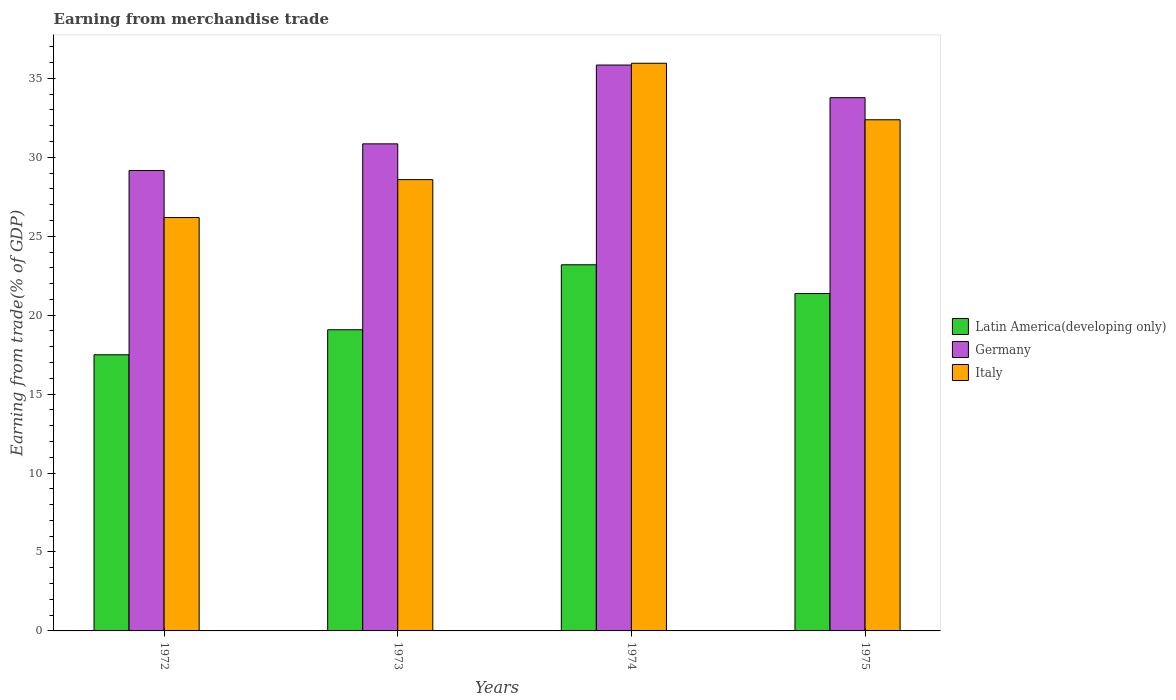How many groups of bars are there?
Give a very brief answer. 4. Are the number of bars per tick equal to the number of legend labels?
Provide a succinct answer. Yes. How many bars are there on the 3rd tick from the left?
Keep it short and to the point. 3. How many bars are there on the 2nd tick from the right?
Ensure brevity in your answer.  3. What is the label of the 2nd group of bars from the left?
Ensure brevity in your answer.  1973. In how many cases, is the number of bars for a given year not equal to the number of legend labels?
Provide a succinct answer. 0. What is the earnings from trade in Germany in 1975?
Your response must be concise. 33.78. Across all years, what is the maximum earnings from trade in Germany?
Provide a short and direct response. 35.85. Across all years, what is the minimum earnings from trade in Germany?
Your response must be concise. 29.17. In which year was the earnings from trade in Latin America(developing only) maximum?
Your answer should be very brief. 1974. In which year was the earnings from trade in Latin America(developing only) minimum?
Provide a succinct answer. 1972. What is the total earnings from trade in Italy in the graph?
Provide a short and direct response. 123.12. What is the difference between the earnings from trade in Germany in 1973 and that in 1975?
Offer a terse response. -2.92. What is the difference between the earnings from trade in Latin America(developing only) in 1973 and the earnings from trade in Italy in 1972?
Provide a short and direct response. -7.11. What is the average earnings from trade in Italy per year?
Provide a short and direct response. 30.78. In the year 1972, what is the difference between the earnings from trade in Germany and earnings from trade in Latin America(developing only)?
Provide a succinct answer. 11.67. In how many years, is the earnings from trade in Italy greater than 6 %?
Offer a terse response. 4. What is the ratio of the earnings from trade in Germany in 1973 to that in 1975?
Offer a very short reply. 0.91. What is the difference between the highest and the second highest earnings from trade in Latin America(developing only)?
Your answer should be very brief. 1.82. What is the difference between the highest and the lowest earnings from trade in Italy?
Your answer should be very brief. 9.77. In how many years, is the earnings from trade in Italy greater than the average earnings from trade in Italy taken over all years?
Keep it short and to the point. 2. What does the 2nd bar from the right in 1974 represents?
Your response must be concise. Germany. Are all the bars in the graph horizontal?
Your response must be concise. No. How many years are there in the graph?
Provide a succinct answer. 4. What is the difference between two consecutive major ticks on the Y-axis?
Make the answer very short. 5. Does the graph contain grids?
Keep it short and to the point. No. How many legend labels are there?
Give a very brief answer. 3. How are the legend labels stacked?
Ensure brevity in your answer.  Vertical. What is the title of the graph?
Your answer should be compact. Earning from merchandise trade. What is the label or title of the Y-axis?
Offer a very short reply. Earning from trade(% of GDP). What is the Earning from trade(% of GDP) in Latin America(developing only) in 1972?
Give a very brief answer. 17.49. What is the Earning from trade(% of GDP) of Germany in 1972?
Your answer should be compact. 29.17. What is the Earning from trade(% of GDP) of Italy in 1972?
Give a very brief answer. 26.19. What is the Earning from trade(% of GDP) of Latin America(developing only) in 1973?
Offer a terse response. 19.08. What is the Earning from trade(% of GDP) in Germany in 1973?
Give a very brief answer. 30.86. What is the Earning from trade(% of GDP) of Italy in 1973?
Your response must be concise. 28.59. What is the Earning from trade(% of GDP) of Latin America(developing only) in 1974?
Your answer should be compact. 23.19. What is the Earning from trade(% of GDP) in Germany in 1974?
Make the answer very short. 35.85. What is the Earning from trade(% of GDP) in Italy in 1974?
Offer a very short reply. 35.96. What is the Earning from trade(% of GDP) in Latin America(developing only) in 1975?
Offer a terse response. 21.38. What is the Earning from trade(% of GDP) in Germany in 1975?
Give a very brief answer. 33.78. What is the Earning from trade(% of GDP) in Italy in 1975?
Your response must be concise. 32.38. Across all years, what is the maximum Earning from trade(% of GDP) in Latin America(developing only)?
Your answer should be compact. 23.19. Across all years, what is the maximum Earning from trade(% of GDP) in Germany?
Your answer should be compact. 35.85. Across all years, what is the maximum Earning from trade(% of GDP) of Italy?
Offer a terse response. 35.96. Across all years, what is the minimum Earning from trade(% of GDP) of Latin America(developing only)?
Ensure brevity in your answer.  17.49. Across all years, what is the minimum Earning from trade(% of GDP) in Germany?
Keep it short and to the point. 29.17. Across all years, what is the minimum Earning from trade(% of GDP) of Italy?
Your response must be concise. 26.19. What is the total Earning from trade(% of GDP) in Latin America(developing only) in the graph?
Offer a terse response. 81.14. What is the total Earning from trade(% of GDP) in Germany in the graph?
Give a very brief answer. 129.65. What is the total Earning from trade(% of GDP) in Italy in the graph?
Keep it short and to the point. 123.12. What is the difference between the Earning from trade(% of GDP) of Latin America(developing only) in 1972 and that in 1973?
Your answer should be compact. -1.59. What is the difference between the Earning from trade(% of GDP) of Germany in 1972 and that in 1973?
Make the answer very short. -1.69. What is the difference between the Earning from trade(% of GDP) in Italy in 1972 and that in 1973?
Offer a terse response. -2.4. What is the difference between the Earning from trade(% of GDP) of Latin America(developing only) in 1972 and that in 1974?
Ensure brevity in your answer.  -5.7. What is the difference between the Earning from trade(% of GDP) in Germany in 1972 and that in 1974?
Your answer should be very brief. -6.68. What is the difference between the Earning from trade(% of GDP) in Italy in 1972 and that in 1974?
Your answer should be very brief. -9.77. What is the difference between the Earning from trade(% of GDP) of Latin America(developing only) in 1972 and that in 1975?
Offer a terse response. -3.88. What is the difference between the Earning from trade(% of GDP) in Germany in 1972 and that in 1975?
Your answer should be very brief. -4.61. What is the difference between the Earning from trade(% of GDP) of Italy in 1972 and that in 1975?
Offer a terse response. -6.19. What is the difference between the Earning from trade(% of GDP) of Latin America(developing only) in 1973 and that in 1974?
Your answer should be compact. -4.12. What is the difference between the Earning from trade(% of GDP) of Germany in 1973 and that in 1974?
Provide a short and direct response. -4.99. What is the difference between the Earning from trade(% of GDP) of Italy in 1973 and that in 1974?
Give a very brief answer. -7.37. What is the difference between the Earning from trade(% of GDP) in Latin America(developing only) in 1973 and that in 1975?
Offer a very short reply. -2.3. What is the difference between the Earning from trade(% of GDP) of Germany in 1973 and that in 1975?
Make the answer very short. -2.92. What is the difference between the Earning from trade(% of GDP) of Italy in 1973 and that in 1975?
Keep it short and to the point. -3.79. What is the difference between the Earning from trade(% of GDP) in Latin America(developing only) in 1974 and that in 1975?
Give a very brief answer. 1.82. What is the difference between the Earning from trade(% of GDP) in Germany in 1974 and that in 1975?
Your response must be concise. 2.07. What is the difference between the Earning from trade(% of GDP) of Italy in 1974 and that in 1975?
Offer a terse response. 3.58. What is the difference between the Earning from trade(% of GDP) of Latin America(developing only) in 1972 and the Earning from trade(% of GDP) of Germany in 1973?
Your answer should be compact. -13.36. What is the difference between the Earning from trade(% of GDP) in Latin America(developing only) in 1972 and the Earning from trade(% of GDP) in Italy in 1973?
Provide a succinct answer. -11.1. What is the difference between the Earning from trade(% of GDP) of Germany in 1972 and the Earning from trade(% of GDP) of Italy in 1973?
Your response must be concise. 0.58. What is the difference between the Earning from trade(% of GDP) in Latin America(developing only) in 1972 and the Earning from trade(% of GDP) in Germany in 1974?
Ensure brevity in your answer.  -18.35. What is the difference between the Earning from trade(% of GDP) of Latin America(developing only) in 1972 and the Earning from trade(% of GDP) of Italy in 1974?
Ensure brevity in your answer.  -18.47. What is the difference between the Earning from trade(% of GDP) of Germany in 1972 and the Earning from trade(% of GDP) of Italy in 1974?
Offer a terse response. -6.79. What is the difference between the Earning from trade(% of GDP) in Latin America(developing only) in 1972 and the Earning from trade(% of GDP) in Germany in 1975?
Ensure brevity in your answer.  -16.29. What is the difference between the Earning from trade(% of GDP) of Latin America(developing only) in 1972 and the Earning from trade(% of GDP) of Italy in 1975?
Your response must be concise. -14.89. What is the difference between the Earning from trade(% of GDP) in Germany in 1972 and the Earning from trade(% of GDP) in Italy in 1975?
Your answer should be very brief. -3.21. What is the difference between the Earning from trade(% of GDP) of Latin America(developing only) in 1973 and the Earning from trade(% of GDP) of Germany in 1974?
Give a very brief answer. -16.77. What is the difference between the Earning from trade(% of GDP) in Latin America(developing only) in 1973 and the Earning from trade(% of GDP) in Italy in 1974?
Your response must be concise. -16.88. What is the difference between the Earning from trade(% of GDP) of Germany in 1973 and the Earning from trade(% of GDP) of Italy in 1974?
Provide a short and direct response. -5.11. What is the difference between the Earning from trade(% of GDP) of Latin America(developing only) in 1973 and the Earning from trade(% of GDP) of Germany in 1975?
Your response must be concise. -14.7. What is the difference between the Earning from trade(% of GDP) in Latin America(developing only) in 1973 and the Earning from trade(% of GDP) in Italy in 1975?
Make the answer very short. -13.3. What is the difference between the Earning from trade(% of GDP) of Germany in 1973 and the Earning from trade(% of GDP) of Italy in 1975?
Make the answer very short. -1.53. What is the difference between the Earning from trade(% of GDP) in Latin America(developing only) in 1974 and the Earning from trade(% of GDP) in Germany in 1975?
Provide a short and direct response. -10.58. What is the difference between the Earning from trade(% of GDP) of Latin America(developing only) in 1974 and the Earning from trade(% of GDP) of Italy in 1975?
Your response must be concise. -9.19. What is the difference between the Earning from trade(% of GDP) in Germany in 1974 and the Earning from trade(% of GDP) in Italy in 1975?
Your answer should be very brief. 3.47. What is the average Earning from trade(% of GDP) in Latin America(developing only) per year?
Your answer should be very brief. 20.29. What is the average Earning from trade(% of GDP) of Germany per year?
Provide a short and direct response. 32.41. What is the average Earning from trade(% of GDP) in Italy per year?
Your answer should be very brief. 30.78. In the year 1972, what is the difference between the Earning from trade(% of GDP) in Latin America(developing only) and Earning from trade(% of GDP) in Germany?
Give a very brief answer. -11.67. In the year 1972, what is the difference between the Earning from trade(% of GDP) of Latin America(developing only) and Earning from trade(% of GDP) of Italy?
Provide a short and direct response. -8.69. In the year 1972, what is the difference between the Earning from trade(% of GDP) in Germany and Earning from trade(% of GDP) in Italy?
Ensure brevity in your answer.  2.98. In the year 1973, what is the difference between the Earning from trade(% of GDP) of Latin America(developing only) and Earning from trade(% of GDP) of Germany?
Offer a terse response. -11.78. In the year 1973, what is the difference between the Earning from trade(% of GDP) in Latin America(developing only) and Earning from trade(% of GDP) in Italy?
Your answer should be very brief. -9.51. In the year 1973, what is the difference between the Earning from trade(% of GDP) of Germany and Earning from trade(% of GDP) of Italy?
Your answer should be compact. 2.27. In the year 1974, what is the difference between the Earning from trade(% of GDP) in Latin America(developing only) and Earning from trade(% of GDP) in Germany?
Keep it short and to the point. -12.65. In the year 1974, what is the difference between the Earning from trade(% of GDP) of Latin America(developing only) and Earning from trade(% of GDP) of Italy?
Offer a terse response. -12.77. In the year 1974, what is the difference between the Earning from trade(% of GDP) in Germany and Earning from trade(% of GDP) in Italy?
Give a very brief answer. -0.11. In the year 1975, what is the difference between the Earning from trade(% of GDP) in Latin America(developing only) and Earning from trade(% of GDP) in Germany?
Your answer should be very brief. -12.4. In the year 1975, what is the difference between the Earning from trade(% of GDP) in Latin America(developing only) and Earning from trade(% of GDP) in Italy?
Your answer should be compact. -11. In the year 1975, what is the difference between the Earning from trade(% of GDP) of Germany and Earning from trade(% of GDP) of Italy?
Provide a short and direct response. 1.4. What is the ratio of the Earning from trade(% of GDP) in Latin America(developing only) in 1972 to that in 1973?
Your answer should be very brief. 0.92. What is the ratio of the Earning from trade(% of GDP) in Germany in 1972 to that in 1973?
Ensure brevity in your answer.  0.95. What is the ratio of the Earning from trade(% of GDP) in Italy in 1972 to that in 1973?
Ensure brevity in your answer.  0.92. What is the ratio of the Earning from trade(% of GDP) of Latin America(developing only) in 1972 to that in 1974?
Your response must be concise. 0.75. What is the ratio of the Earning from trade(% of GDP) in Germany in 1972 to that in 1974?
Ensure brevity in your answer.  0.81. What is the ratio of the Earning from trade(% of GDP) of Italy in 1972 to that in 1974?
Your answer should be very brief. 0.73. What is the ratio of the Earning from trade(% of GDP) of Latin America(developing only) in 1972 to that in 1975?
Make the answer very short. 0.82. What is the ratio of the Earning from trade(% of GDP) in Germany in 1972 to that in 1975?
Your response must be concise. 0.86. What is the ratio of the Earning from trade(% of GDP) of Italy in 1972 to that in 1975?
Provide a short and direct response. 0.81. What is the ratio of the Earning from trade(% of GDP) of Latin America(developing only) in 1973 to that in 1974?
Offer a terse response. 0.82. What is the ratio of the Earning from trade(% of GDP) in Germany in 1973 to that in 1974?
Your response must be concise. 0.86. What is the ratio of the Earning from trade(% of GDP) of Italy in 1973 to that in 1974?
Provide a short and direct response. 0.8. What is the ratio of the Earning from trade(% of GDP) in Latin America(developing only) in 1973 to that in 1975?
Give a very brief answer. 0.89. What is the ratio of the Earning from trade(% of GDP) of Germany in 1973 to that in 1975?
Your answer should be compact. 0.91. What is the ratio of the Earning from trade(% of GDP) in Italy in 1973 to that in 1975?
Your response must be concise. 0.88. What is the ratio of the Earning from trade(% of GDP) of Latin America(developing only) in 1974 to that in 1975?
Give a very brief answer. 1.09. What is the ratio of the Earning from trade(% of GDP) of Germany in 1974 to that in 1975?
Provide a short and direct response. 1.06. What is the ratio of the Earning from trade(% of GDP) in Italy in 1974 to that in 1975?
Your answer should be compact. 1.11. What is the difference between the highest and the second highest Earning from trade(% of GDP) in Latin America(developing only)?
Ensure brevity in your answer.  1.82. What is the difference between the highest and the second highest Earning from trade(% of GDP) in Germany?
Keep it short and to the point. 2.07. What is the difference between the highest and the second highest Earning from trade(% of GDP) of Italy?
Give a very brief answer. 3.58. What is the difference between the highest and the lowest Earning from trade(% of GDP) in Latin America(developing only)?
Your answer should be very brief. 5.7. What is the difference between the highest and the lowest Earning from trade(% of GDP) in Germany?
Ensure brevity in your answer.  6.68. What is the difference between the highest and the lowest Earning from trade(% of GDP) of Italy?
Give a very brief answer. 9.77. 